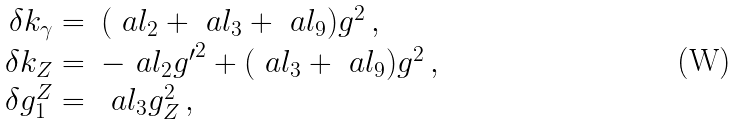Convert formula to latex. <formula><loc_0><loc_0><loc_500><loc_500>\begin{array} { r l } \delta k _ { \gamma } = & ( \ a l _ { 2 } + \ a l _ { 3 } + \ a l _ { 9 } ) g ^ { 2 } \, , \\ \delta k _ { Z } = & - \ a l _ { 2 } { g ^ { \prime } } ^ { 2 } + ( \ a l _ { 3 } + \ a l _ { 9 } ) g ^ { 2 } \, , \\ \delta g ^ { Z } _ { 1 } = & \ a l _ { 3 } g _ { Z } ^ { 2 } \, , \end{array}</formula> 